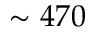Convert formula to latex. <formula><loc_0><loc_0><loc_500><loc_500>\sim 4 7 0</formula> 